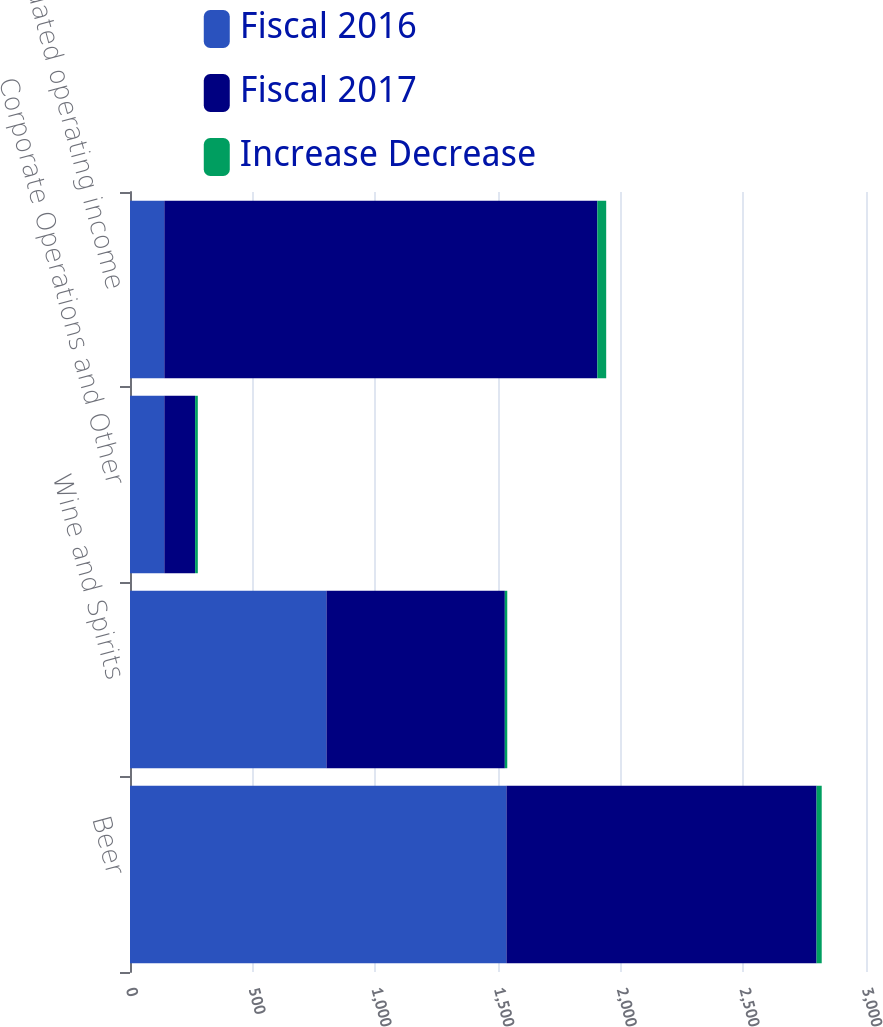Convert chart. <chart><loc_0><loc_0><loc_500><loc_500><stacked_bar_chart><ecel><fcel>Beer<fcel>Wine and Spirits<fcel>Corporate Operations and Other<fcel>Consolidated operating income<nl><fcel>Fiscal 2016<fcel>1534.4<fcel>800.8<fcel>139.9<fcel>139.9<nl><fcel>Fiscal 2017<fcel>1264.1<fcel>727<fcel>125.5<fcel>1765.1<nl><fcel>Increase Decrease<fcel>21<fcel>10<fcel>11<fcel>36<nl></chart> 